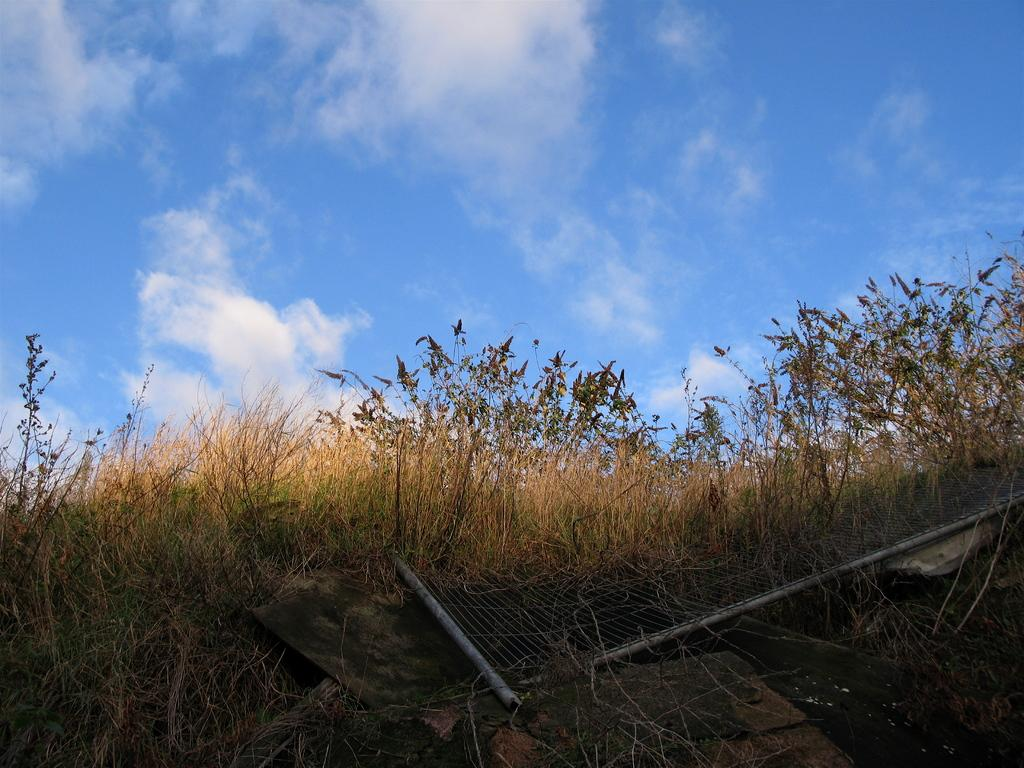What is located in the foreground of the image? There is a metal fence and a group of trees in the foreground of the image. What can be seen in the background of the image? The sky is visible in the background of the image. How would you describe the sky in the image? The sky appears to be cloudy. How many turkeys are sitting on the eggs in the cart in the image? There are no turkeys, eggs, or carts present in the image. 